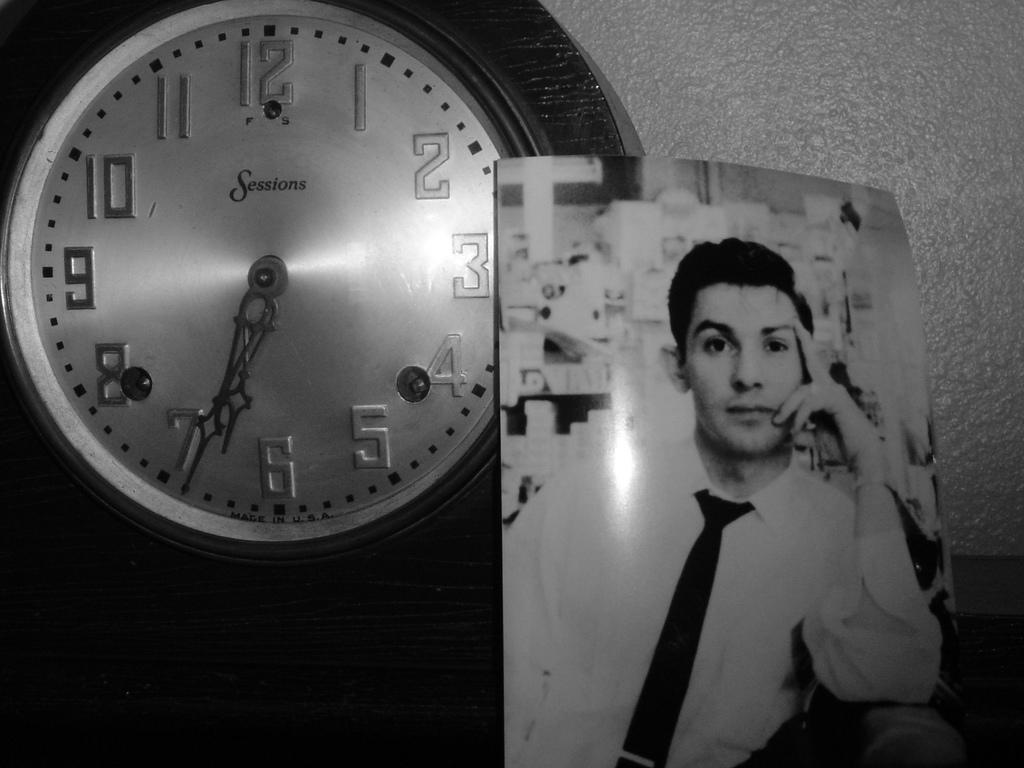<image>
Write a terse but informative summary of the picture. Photo next to a clock which says "Sessions" on the face. 